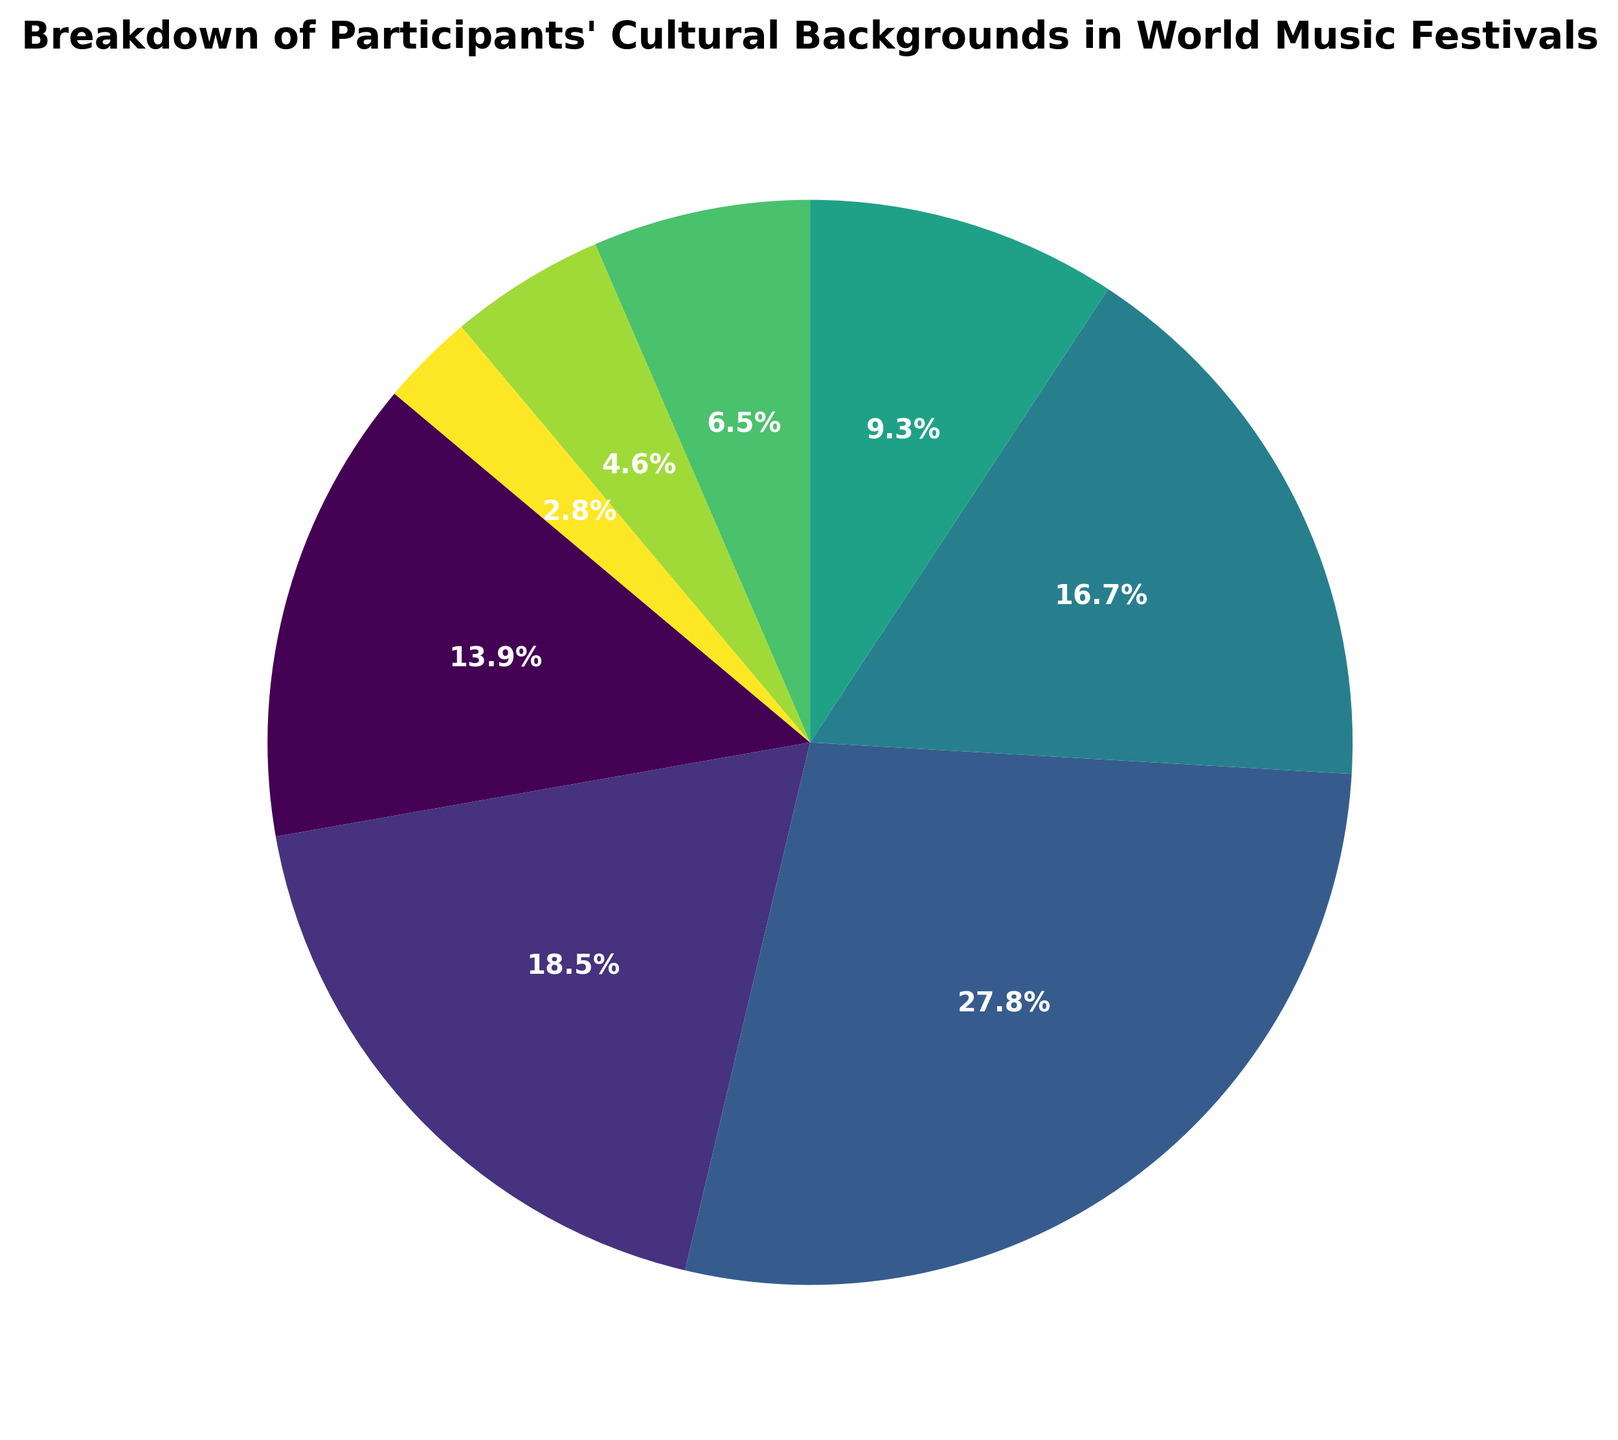Which cultural background has the highest percentage of participants? Looking at the percentages, "European" has the highest with 30%.
Answer: European Which two cultural backgrounds together make up 35% of the participants? Adding the percentages, 20% (African) + 15% (Andean) equals 35%.
Answer: African and Andean By how much does the percentage of participants from Asian cultural backgrounds exceed those from Middle Eastern cultural backgrounds? The percentage for Asian is 18%, and for Middle Eastern, it is 10%. So, 18% - 10% = 8%.
Answer: 8% Which cultural background has the smallest representation? According to the percentages, "North American Indigenous" has the smallest representation with 3%.
Answer: North American Indigenous What is the combined percentage of participants from Latin American and Pacific Islander cultural backgrounds? Adding the percentages, 7% (Latin American) + 5% (Pacific Islander) equals 12%.
Answer: 12% Which cultural backgrounds share the same color intensity in the pie chart? The pie chart uses a continuous color gradient. "African" and "Asian" have similar color intensities because they are close in percentage and therefore colors.
Answer: African and Asian Is the percentage of participants from African backgrounds greater than the combined percentage of Middle Eastern and North American Indigenous backgrounds? The percentage for African is 20%, and combined for Middle Eastern and North American Indigenous is 10% + 3% = 13%. 20% > 13%.
Answer: Yes Which two cultural backgrounds together surpass the percentage of the European background? Calculating the sums: Asian (18%) + African (20%) = 38%, which is more than European at 30%.
Answer: Asian and African What fraction of the total percentage is made up by Andean participants? The percentage for Andean is 15%. To find the fraction, 15% out of 100% is 15/100, which simplifies to 3/20.
Answer: 3/20 Among the cultural backgrounds, which one is depicted closest to the 3-o'clock position on the pie chart? The pie chart start angle is 140°. The section closest to the 3-o'clock position based on start angle would be the section immediately after 140°, which is "European".
Answer: European 